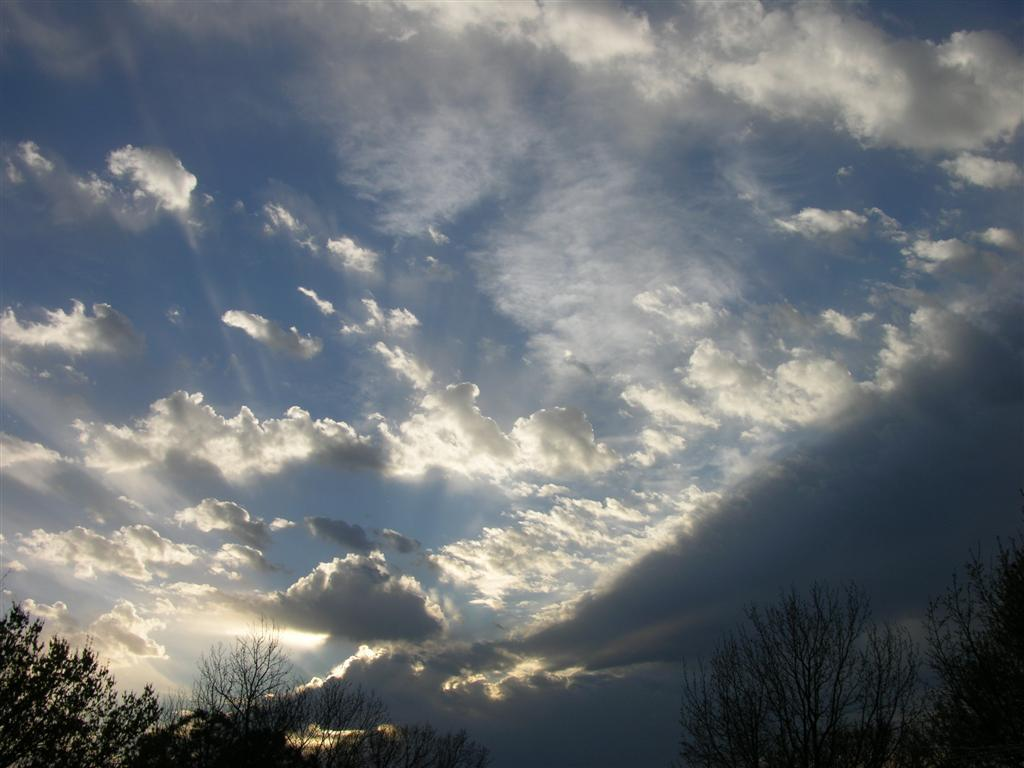What type of vegetation can be seen in the image? There are trees in the image. Where are the trees located in relation to the image? The trees are in the foreground of the image. What can be seen in the background of the image? The sky is visible in the background of the image. How would you describe the sky in the image? The sky is cloudy in the image. What type of nail is being used to hold the idea in the image? There is no nail or idea present in the image; it only features trees and a cloudy sky. 